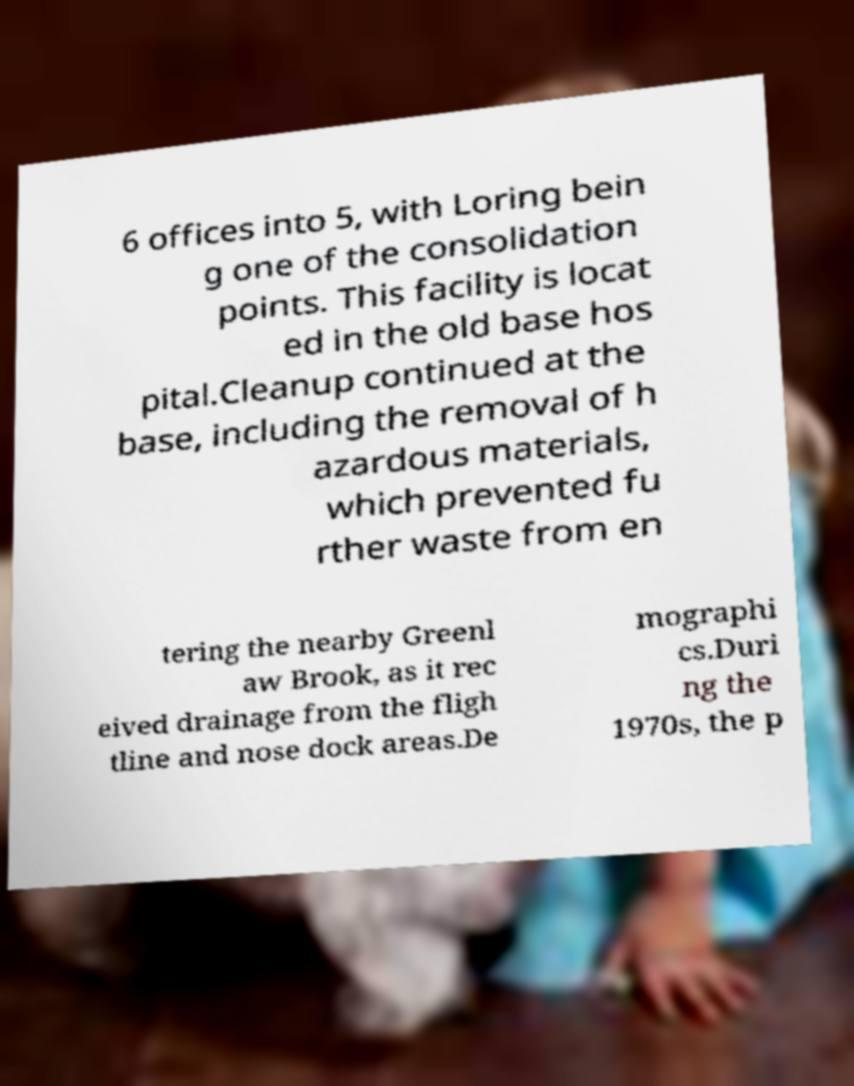There's text embedded in this image that I need extracted. Can you transcribe it verbatim? 6 offices into 5, with Loring bein g one of the consolidation points. This facility is locat ed in the old base hos pital.Cleanup continued at the base, including the removal of h azardous materials, which prevented fu rther waste from en tering the nearby Greenl aw Brook, as it rec eived drainage from the fligh tline and nose dock areas.De mographi cs.Duri ng the 1970s, the p 